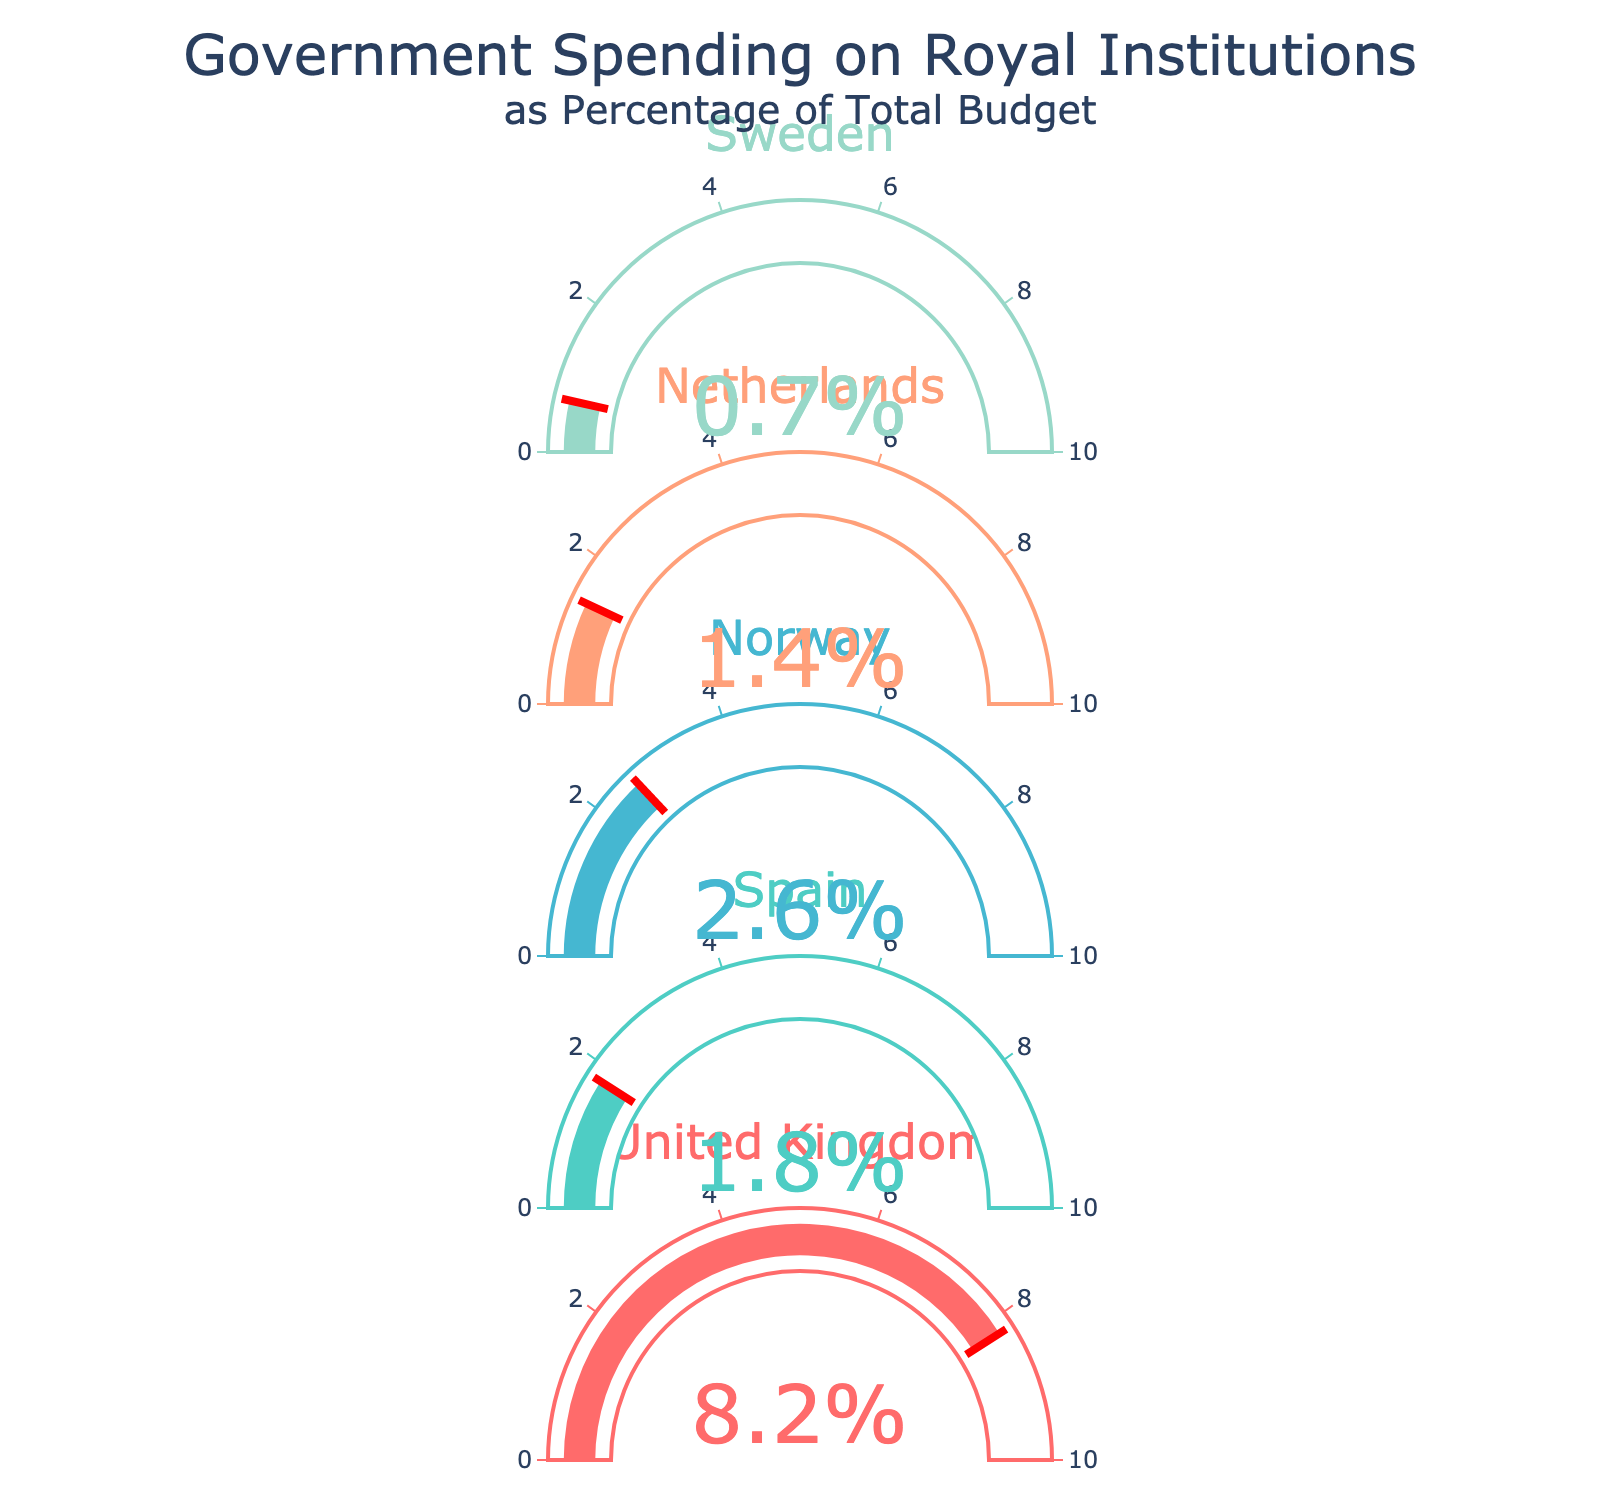What's the highest percentage of government spending on royal institutions shown? The gauge chart for each country displays a value as a percentage. By visually comparing these values, the highest percentage is 0.082 for the United Kingdom.
Answer: 0.082 Which country has the lowest percentage of its budget spent on royal institutions? By examining the values displayed on each gauge, Sweden has the lowest percentage of government spending on royal institutions at 0.007.
Answer: Sweden What is the combined percentage of the total budget spent on royal institutions by Norway and the Netherlands? The percentage for Norway is 0.026 and for the Netherlands is 0.014. Adding these together gives 0.026 + 0.014 = 0.040.
Answer: 0.040 How much greater is the United Kingdom's spending percentage compared to Spain's? The United Kingdom's percentage is 0.082 and Spain's is 0.018. Subtracting Spain's percentage from the United Kingdom's gives 0.082 - 0.018 = 0.064.
Answer: 0.064 Rank the countries from highest to lowest percentage of their budget spent on royal institutions. By ordering the percentages displayed on each gauge for the countries, the ranking from highest to lowest is: United Kingdom (0.082), Norway (0.026), Spain (0.018), Netherlands (0.014), and Sweden (0.007).
Answer: United Kingdom, Norway, Spain, Netherlands, Sweden What is the average percentage of government spending on royal institutions among these countries? Add all the percentages (0.082 + 0.018 + 0.026 + 0.014 + 0.007) to get 0.147, and divide by the number of countries (5). 0.147 / 5 = 0.0294.
Answer: 0.0294 